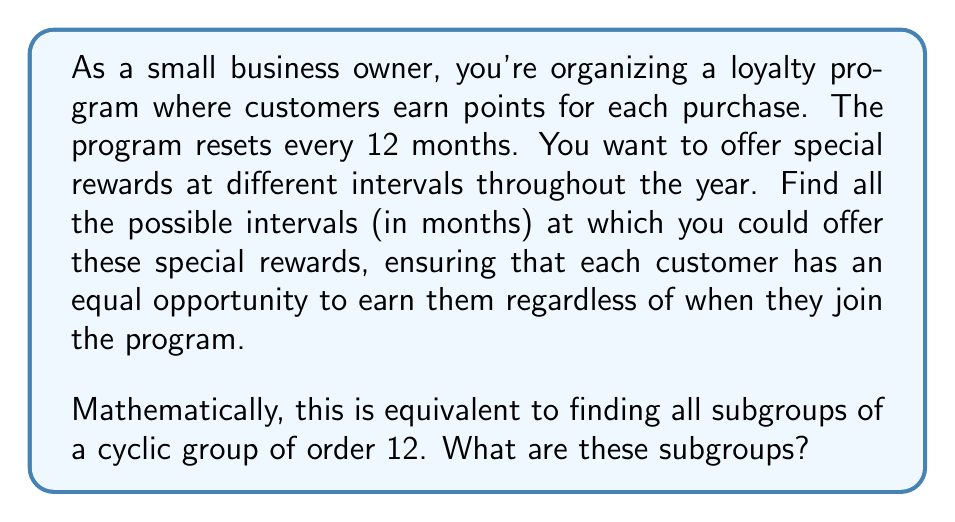Give your solution to this math problem. To solve this problem, we need to understand the structure of a cyclic group of order 12 and its subgroups. Let's approach this step-by-step:

1) A cyclic group of order 12 can be represented as $C_{12} = \langle a \rangle = \{e, a, a^2, ..., a^{11}\}$, where $a^{12} = e$ (the identity element).

2) The subgroups of a cyclic group are always cyclic. They are generated by elements $a^k$ where $k$ divides the order of the group.

3) The divisors of 12 are 1, 2, 3, 4, 6, and 12.

4) For each divisor $d$ of 12, there is a unique subgroup of order $d$. This subgroup is generated by $a^{12/d}$.

5) Let's find these subgroups:

   - For $d = 1$: $\langle a^{12} \rangle = \{e\}$ (the trivial subgroup)
   - For $d = 2$: $\langle a^6 \rangle = \{e, a^6\}$
   - For $d = 3$: $\langle a^4 \rangle = \{e, a^4, a^8\}$
   - For $d = 4$: $\langle a^3 \rangle = \{e, a^3, a^6, a^9\}$
   - For $d = 6$: $\langle a^2 \rangle = \{e, a^2, a^4, a^6, a^8, a^{10}\}$
   - For $d = 12$: $\langle a \rangle = C_{12}$ (the entire group)

6) In terms of the loyalty program, these subgroups correspond to offering special rewards every:
   12 months (1 year), 6 months, 4 months, 3 months, 2 months, and 1 month respectively.
Answer: The subgroups of a cyclic group of order 12 are:

$$\{e\}, \{e, a^6\}, \{e, a^4, a^8\}, \{e, a^3, a^6, a^9\}, \{e, a^2, a^4, a^6, a^8, a^{10}\}, \{e, a, a^2, a^3, a^4, a^5, a^6, a^7, a^8, a^9, a^{10}, a^{11}\}$$

These correspond to reward intervals of 12, 6, 4, 3, 2, and 1 month(s) respectively in the loyalty program context. 